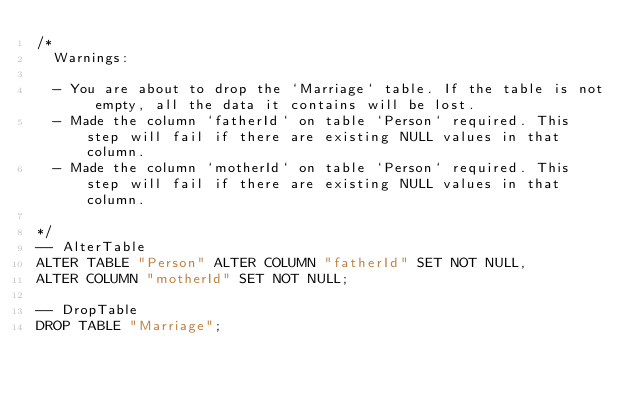Convert code to text. <code><loc_0><loc_0><loc_500><loc_500><_SQL_>/*
  Warnings:

  - You are about to drop the `Marriage` table. If the table is not empty, all the data it contains will be lost.
  - Made the column `fatherId` on table `Person` required. This step will fail if there are existing NULL values in that column.
  - Made the column `motherId` on table `Person` required. This step will fail if there are existing NULL values in that column.

*/
-- AlterTable
ALTER TABLE "Person" ALTER COLUMN "fatherId" SET NOT NULL,
ALTER COLUMN "motherId" SET NOT NULL;

-- DropTable
DROP TABLE "Marriage";
</code> 